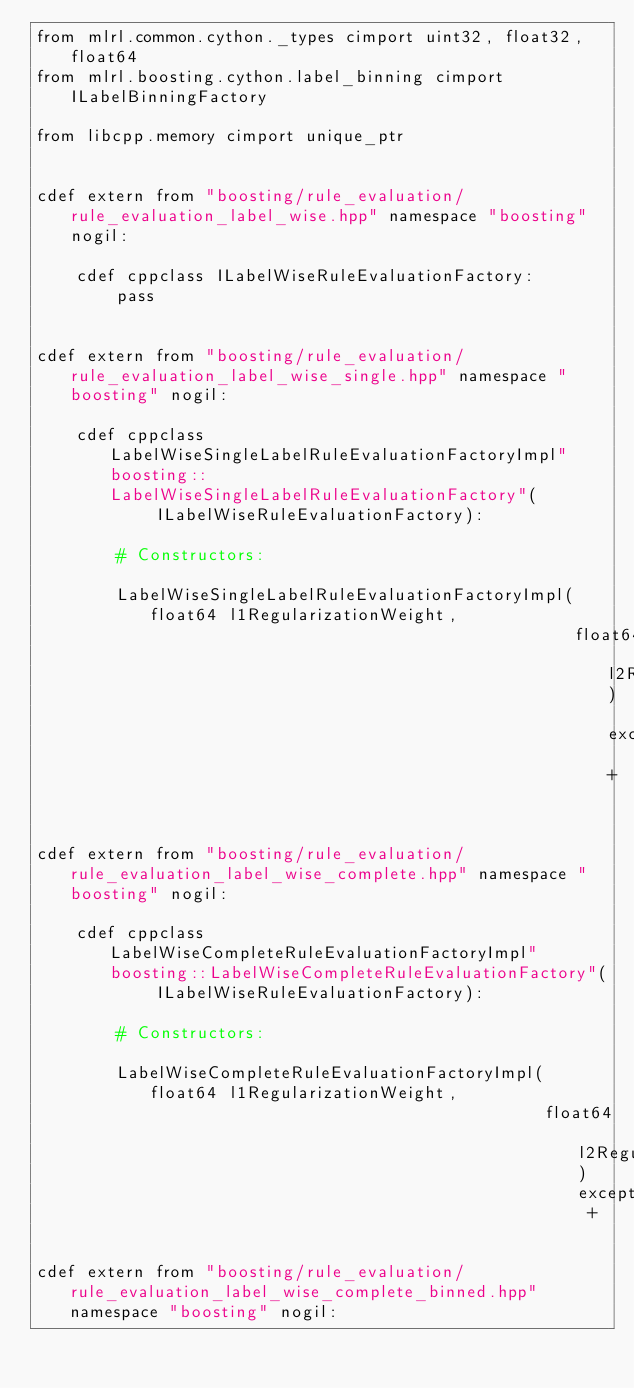<code> <loc_0><loc_0><loc_500><loc_500><_Cython_>from mlrl.common.cython._types cimport uint32, float32, float64
from mlrl.boosting.cython.label_binning cimport ILabelBinningFactory

from libcpp.memory cimport unique_ptr


cdef extern from "boosting/rule_evaluation/rule_evaluation_label_wise.hpp" namespace "boosting" nogil:

    cdef cppclass ILabelWiseRuleEvaluationFactory:
        pass


cdef extern from "boosting/rule_evaluation/rule_evaluation_label_wise_single.hpp" namespace "boosting" nogil:

    cdef cppclass LabelWiseSingleLabelRuleEvaluationFactoryImpl"boosting::LabelWiseSingleLabelRuleEvaluationFactory"(
            ILabelWiseRuleEvaluationFactory):

        # Constructors:

        LabelWiseSingleLabelRuleEvaluationFactoryImpl(float64 l1RegularizationWeight,
                                                      float64 l2RegularizationWeight) except +


cdef extern from "boosting/rule_evaluation/rule_evaluation_label_wise_complete.hpp" namespace "boosting" nogil:

    cdef cppclass LabelWiseCompleteRuleEvaluationFactoryImpl"boosting::LabelWiseCompleteRuleEvaluationFactory"(
            ILabelWiseRuleEvaluationFactory):

        # Constructors:

        LabelWiseCompleteRuleEvaluationFactoryImpl(float64 l1RegularizationWeight,
                                                   float64 l2RegularizationWeight) except +


cdef extern from "boosting/rule_evaluation/rule_evaluation_label_wise_complete_binned.hpp" namespace "boosting" nogil:
</code> 